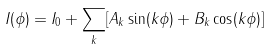Convert formula to latex. <formula><loc_0><loc_0><loc_500><loc_500>I ( \phi ) = I _ { 0 } + \sum _ { k } [ A _ { k } \sin ( k \phi ) + B _ { k } \cos ( k \phi ) ]</formula> 